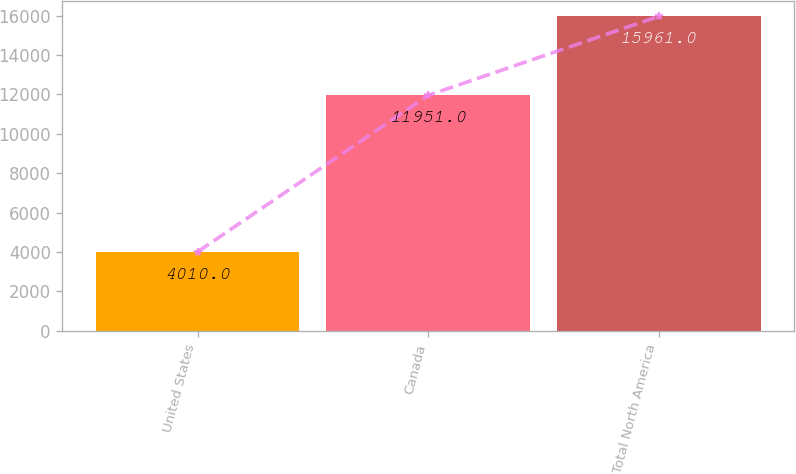Convert chart to OTSL. <chart><loc_0><loc_0><loc_500><loc_500><bar_chart><fcel>United States<fcel>Canada<fcel>Total North America<nl><fcel>4010<fcel>11951<fcel>15961<nl></chart> 